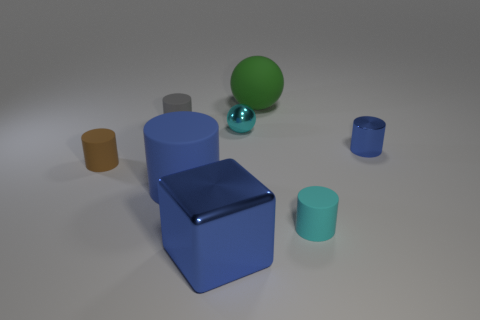Subtract all tiny gray cylinders. How many cylinders are left? 4 Subtract all cyan cylinders. How many cylinders are left? 4 Subtract all purple cylinders. Subtract all purple cubes. How many cylinders are left? 5 Add 2 tiny cyan balls. How many objects exist? 10 Subtract all balls. How many objects are left? 6 Subtract all blue metallic objects. Subtract all red balls. How many objects are left? 6 Add 6 blue things. How many blue things are left? 9 Add 4 brown cylinders. How many brown cylinders exist? 5 Subtract 0 green blocks. How many objects are left? 8 